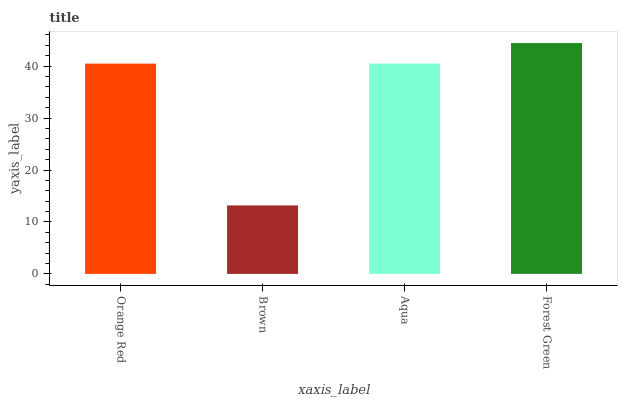Is Brown the minimum?
Answer yes or no. Yes. Is Forest Green the maximum?
Answer yes or no. Yes. Is Aqua the minimum?
Answer yes or no. No. Is Aqua the maximum?
Answer yes or no. No. Is Aqua greater than Brown?
Answer yes or no. Yes. Is Brown less than Aqua?
Answer yes or no. Yes. Is Brown greater than Aqua?
Answer yes or no. No. Is Aqua less than Brown?
Answer yes or no. No. Is Aqua the high median?
Answer yes or no. Yes. Is Orange Red the low median?
Answer yes or no. Yes. Is Orange Red the high median?
Answer yes or no. No. Is Forest Green the low median?
Answer yes or no. No. 